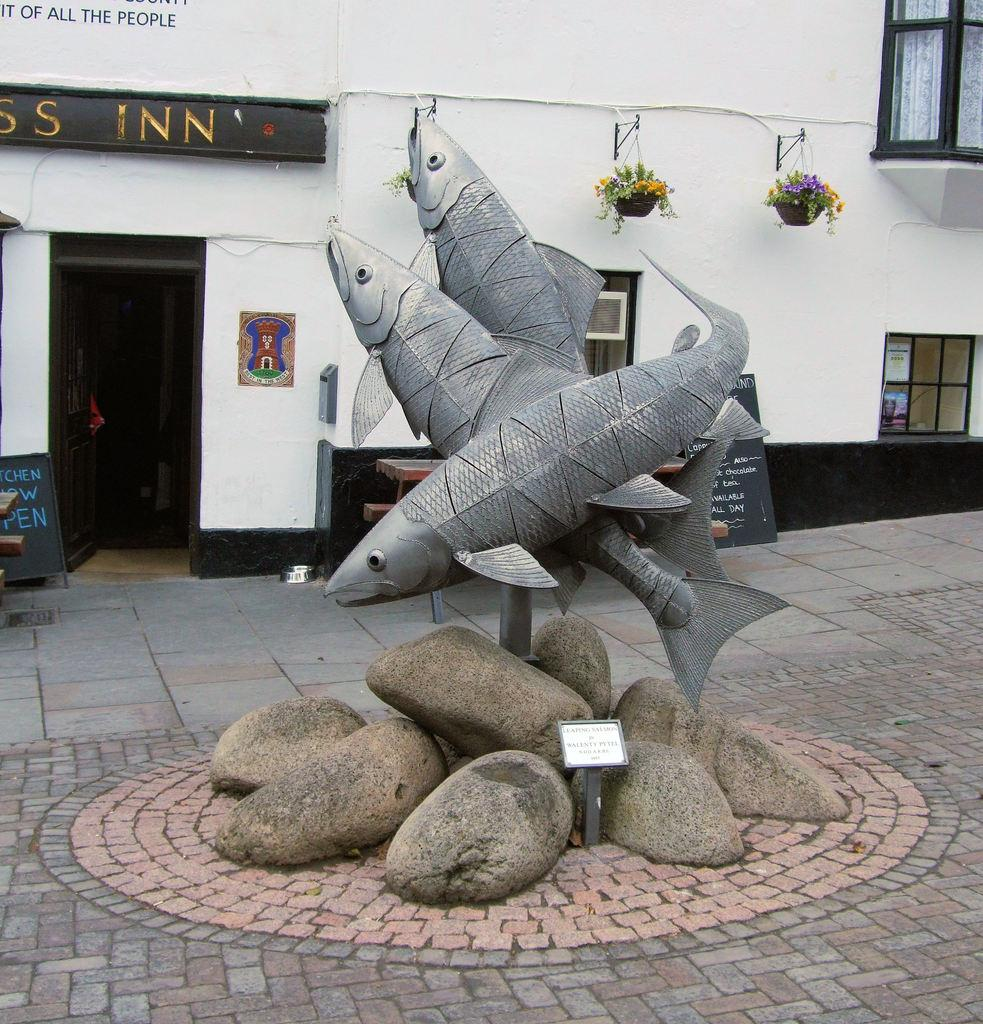What is the main subject of the sculpture in the image? The sculpture in the image is of fishes. What other objects can be seen in the image besides the sculpture? There are boards and rocks visible in the image. What can be seen in the background of the image? There is a building with windows and plants in the background of the image. What type of scent can be detected from the cows in the image? There are no cows present in the image, so it is not possible to detect any scent from them. 